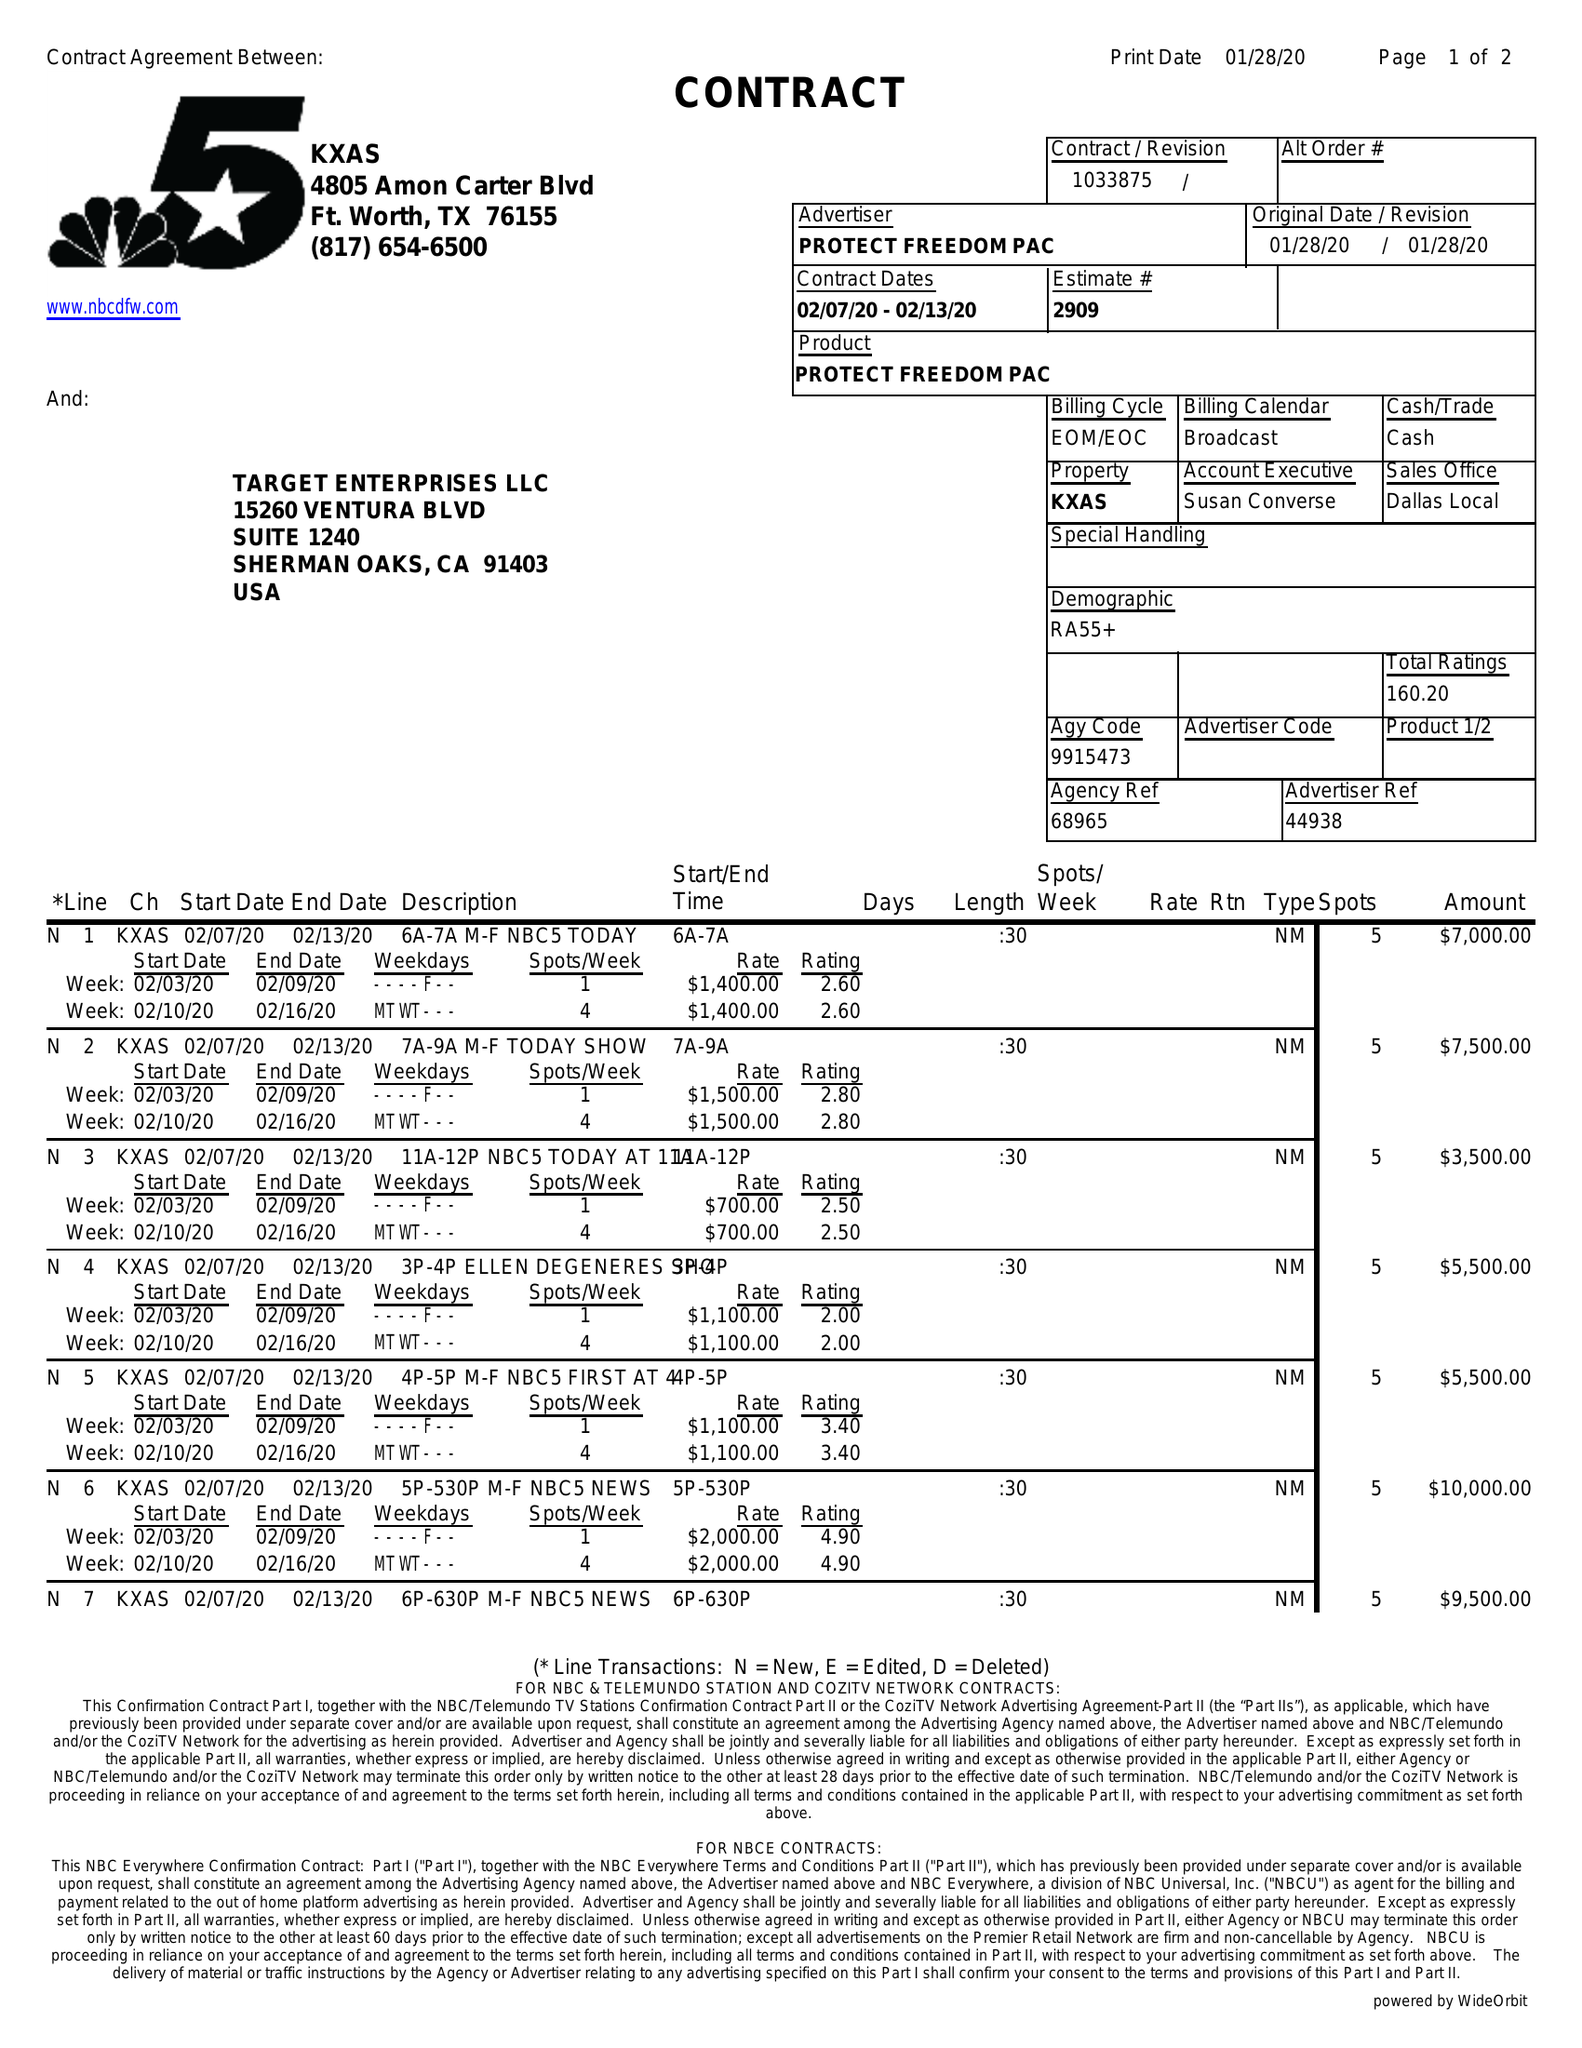What is the value for the flight_from?
Answer the question using a single word or phrase. 02/07/20 